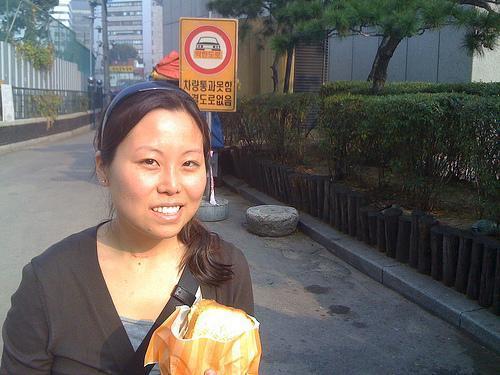How many earrings are visible on the woman?
Give a very brief answer. 1. 